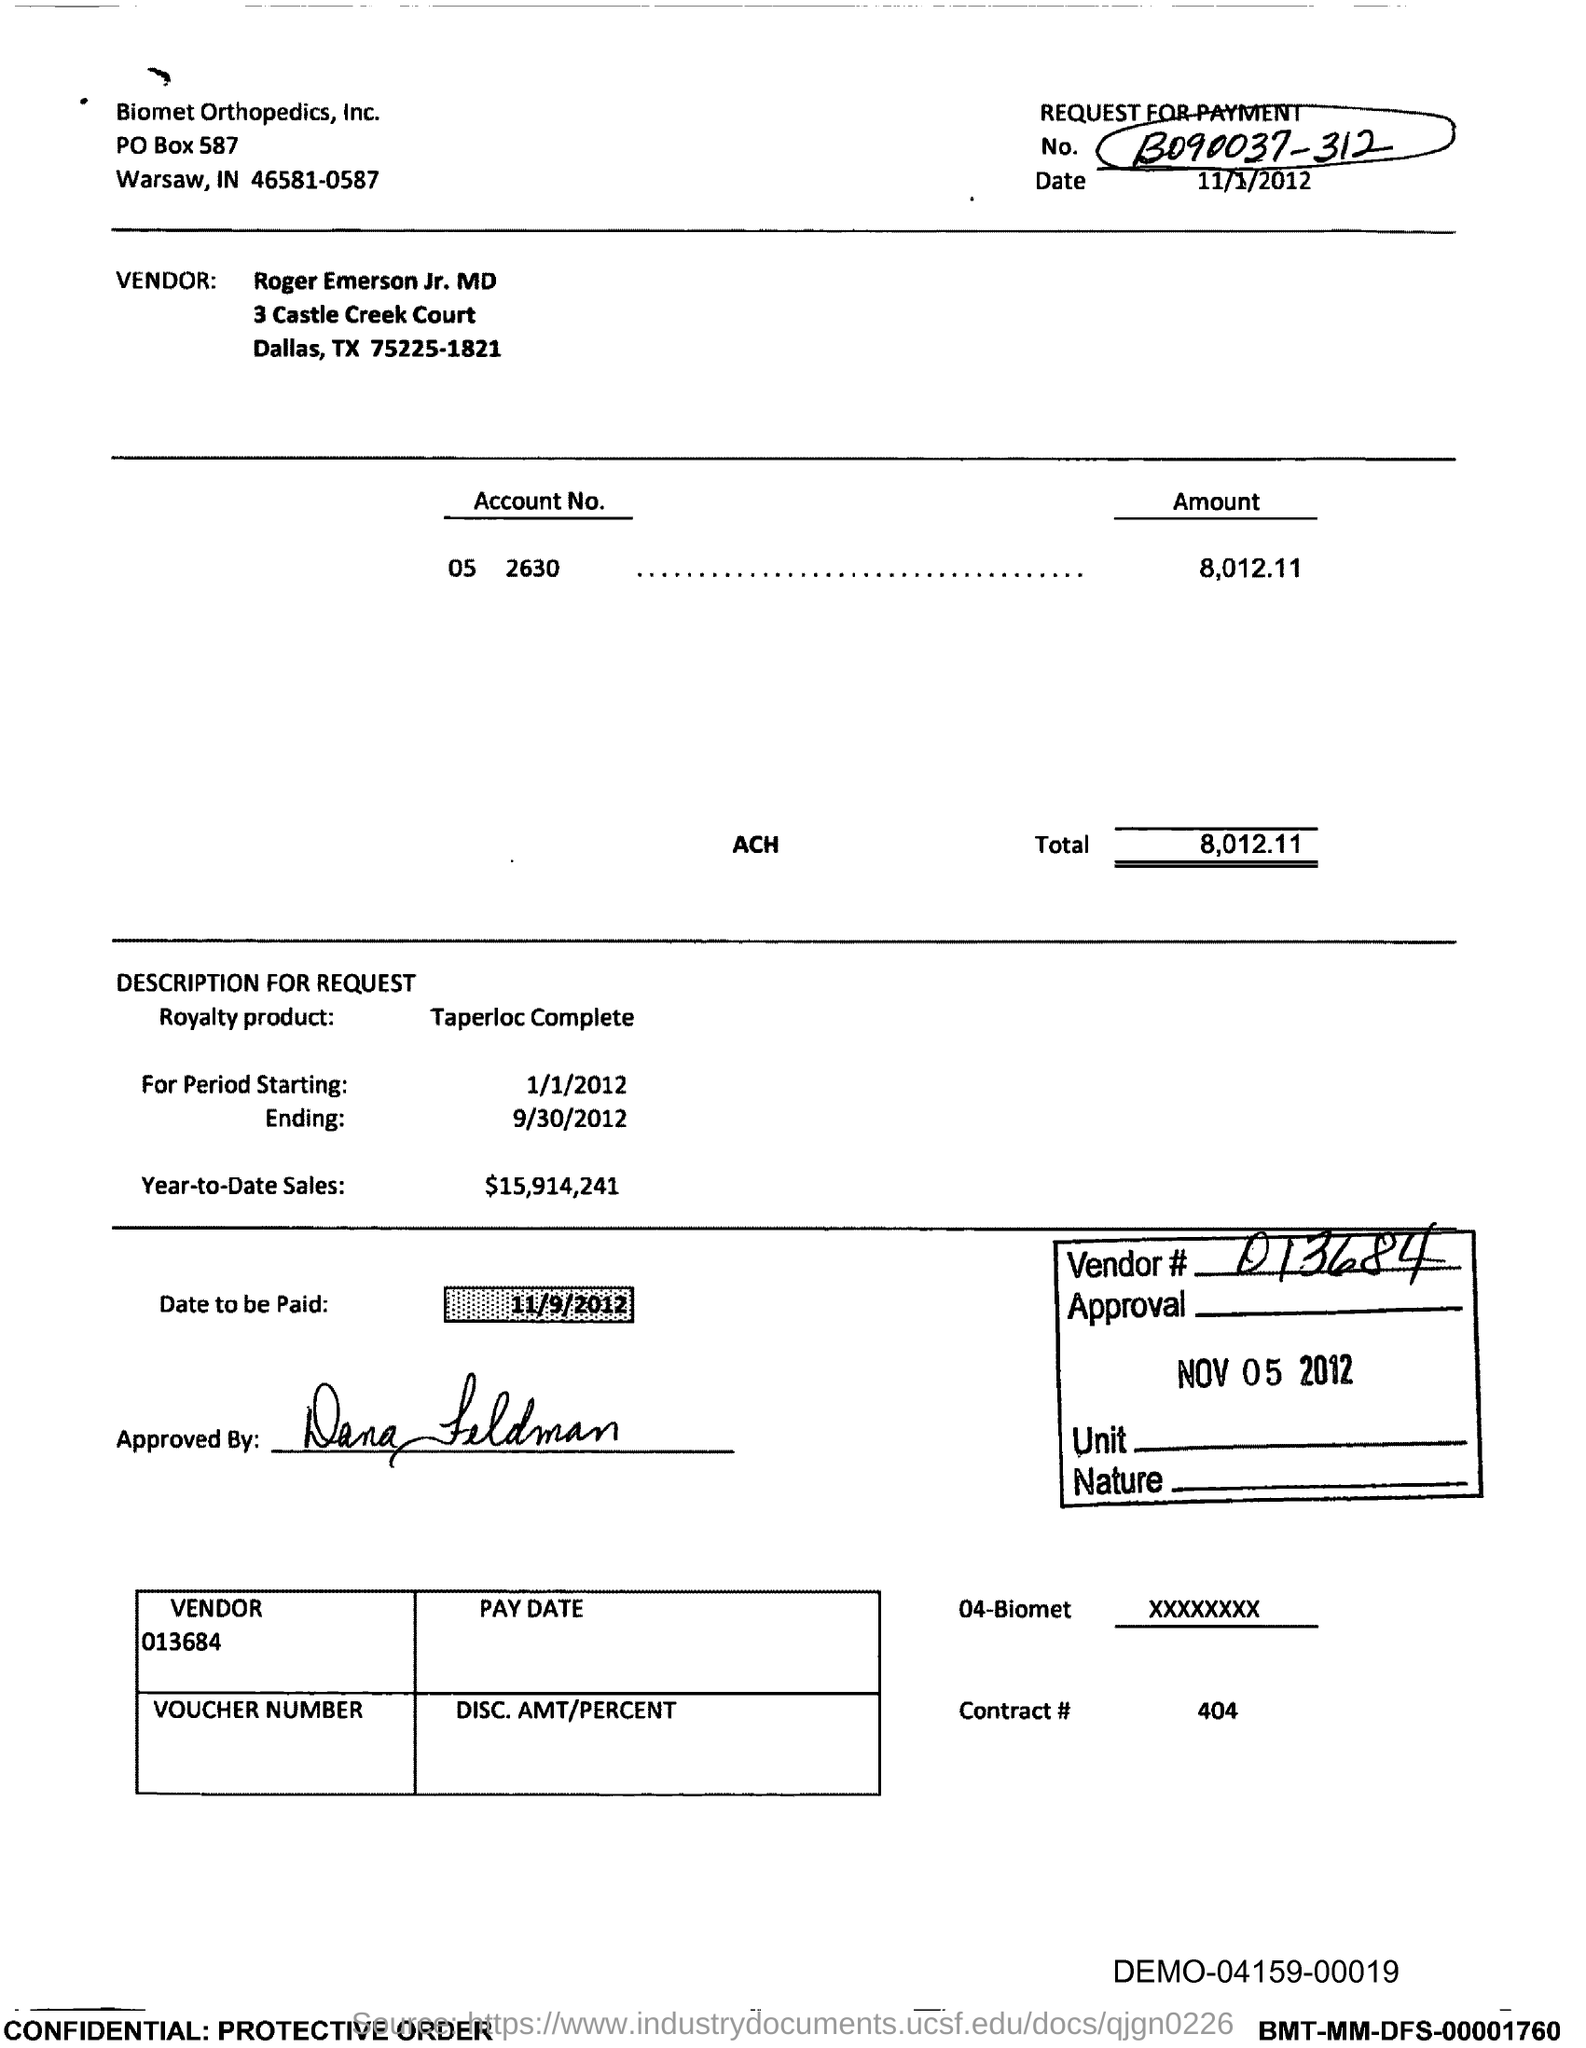What is the number written at the top right?
Make the answer very short. B090037-312. What is the date given?
Make the answer very short. 11/1/2012. Who is the vendor?
Provide a succinct answer. Roger Emerson Jr. MD. What is the total amount in the account?
Your response must be concise. 8,012.11. What is the Royalty product mentioned?
Your answer should be compact. Taperloc Complete. What is the vendor number?
Give a very brief answer. 013684. What is the date to be paid?
Make the answer very short. 11/9/2012. 